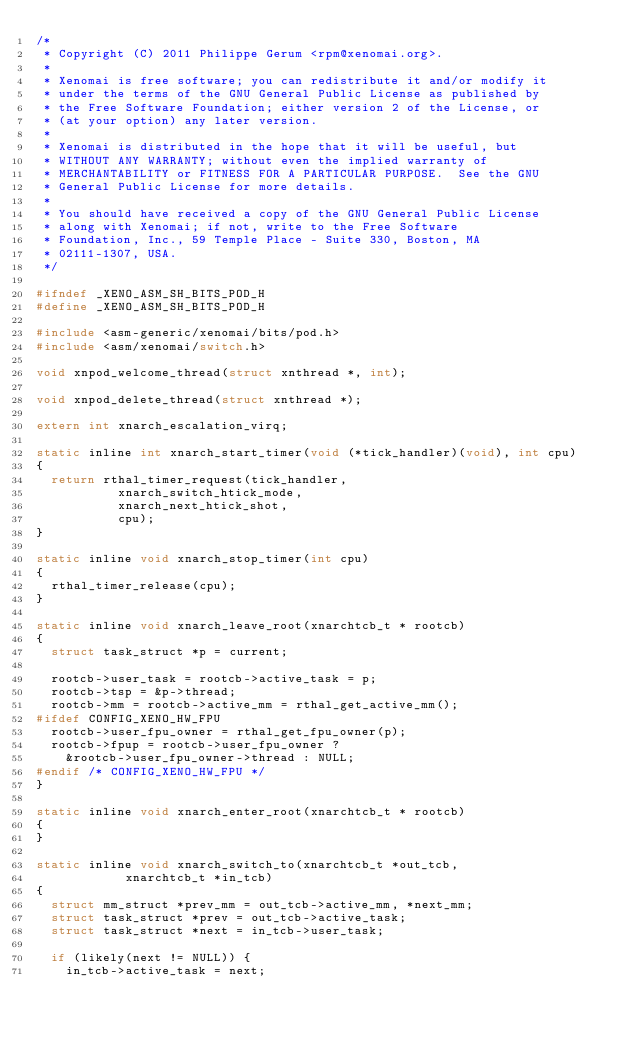<code> <loc_0><loc_0><loc_500><loc_500><_C_>/*
 * Copyright (C) 2011 Philippe Gerum <rpm@xenomai.org>.
 *
 * Xenomai is free software; you can redistribute it and/or modify it
 * under the terms of the GNU General Public License as published by
 * the Free Software Foundation; either version 2 of the License, or
 * (at your option) any later version.
 *
 * Xenomai is distributed in the hope that it will be useful, but
 * WITHOUT ANY WARRANTY; without even the implied warranty of
 * MERCHANTABILITY or FITNESS FOR A PARTICULAR PURPOSE.  See the GNU
 * General Public License for more details.
 *
 * You should have received a copy of the GNU General Public License
 * along with Xenomai; if not, write to the Free Software
 * Foundation, Inc., 59 Temple Place - Suite 330, Boston, MA
 * 02111-1307, USA.
 */

#ifndef _XENO_ASM_SH_BITS_POD_H
#define _XENO_ASM_SH_BITS_POD_H

#include <asm-generic/xenomai/bits/pod.h>
#include <asm/xenomai/switch.h>

void xnpod_welcome_thread(struct xnthread *, int);

void xnpod_delete_thread(struct xnthread *);

extern int xnarch_escalation_virq;

static inline int xnarch_start_timer(void (*tick_handler)(void), int cpu)
{
	return rthal_timer_request(tick_handler,
				   xnarch_switch_htick_mode,
				   xnarch_next_htick_shot,
				   cpu);
}

static inline void xnarch_stop_timer(int cpu)
{
	rthal_timer_release(cpu);
}

static inline void xnarch_leave_root(xnarchtcb_t * rootcb)
{
	struct task_struct *p = current;

	rootcb->user_task = rootcb->active_task = p;
	rootcb->tsp = &p->thread;
	rootcb->mm = rootcb->active_mm = rthal_get_active_mm();
#ifdef CONFIG_XENO_HW_FPU
	rootcb->user_fpu_owner = rthal_get_fpu_owner(p);
	rootcb->fpup = rootcb->user_fpu_owner ?
		&rootcb->user_fpu_owner->thread : NULL;
#endif /* CONFIG_XENO_HW_FPU */
}

static inline void xnarch_enter_root(xnarchtcb_t * rootcb)
{
}

static inline void xnarch_switch_to(xnarchtcb_t *out_tcb,
				    xnarchtcb_t *in_tcb)
{
	struct mm_struct *prev_mm = out_tcb->active_mm, *next_mm;
	struct task_struct *prev = out_tcb->active_task;
	struct task_struct *next = in_tcb->user_task;

	if (likely(next != NULL)) {
		in_tcb->active_task = next;</code> 